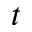<formula> <loc_0><loc_0><loc_500><loc_500>t</formula> 